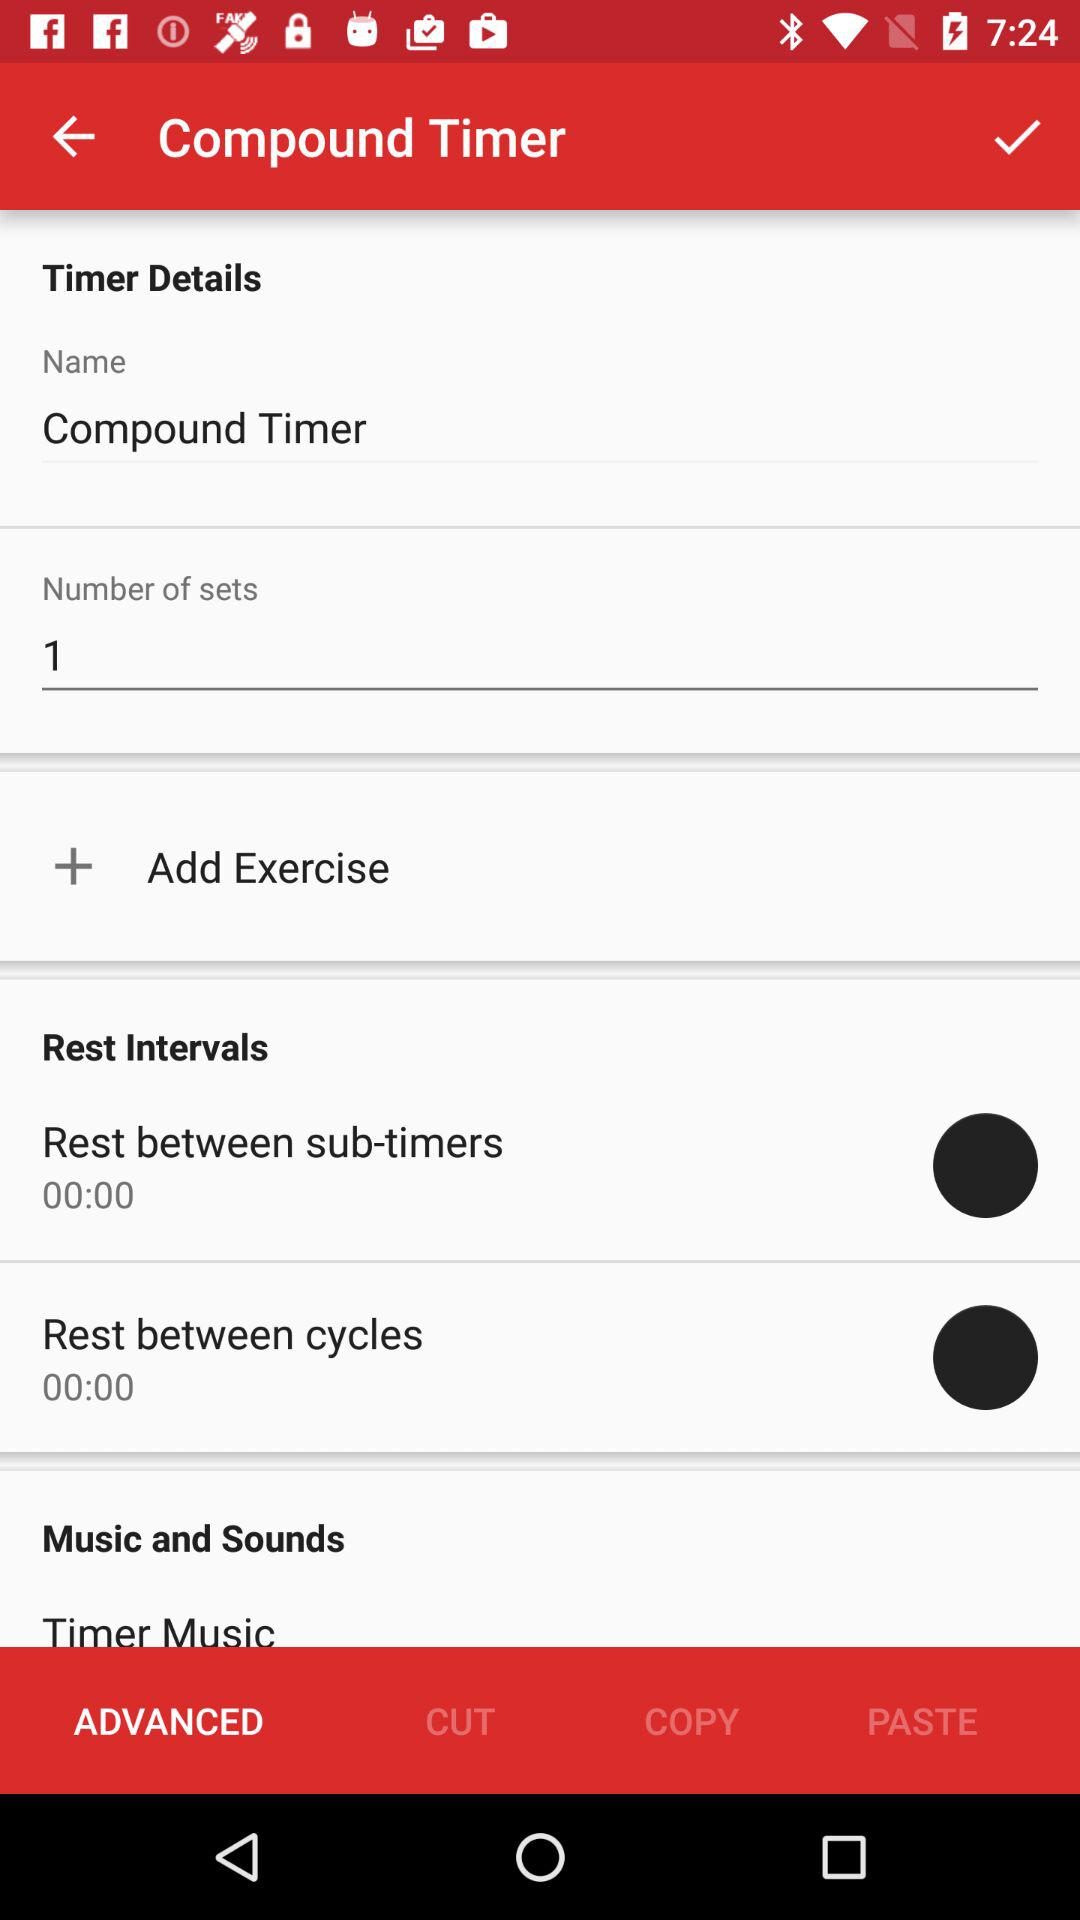What is the duration mentioned in "Rest between cycles"? The duration mentioned in "Rest between cycles" is 0:00. 